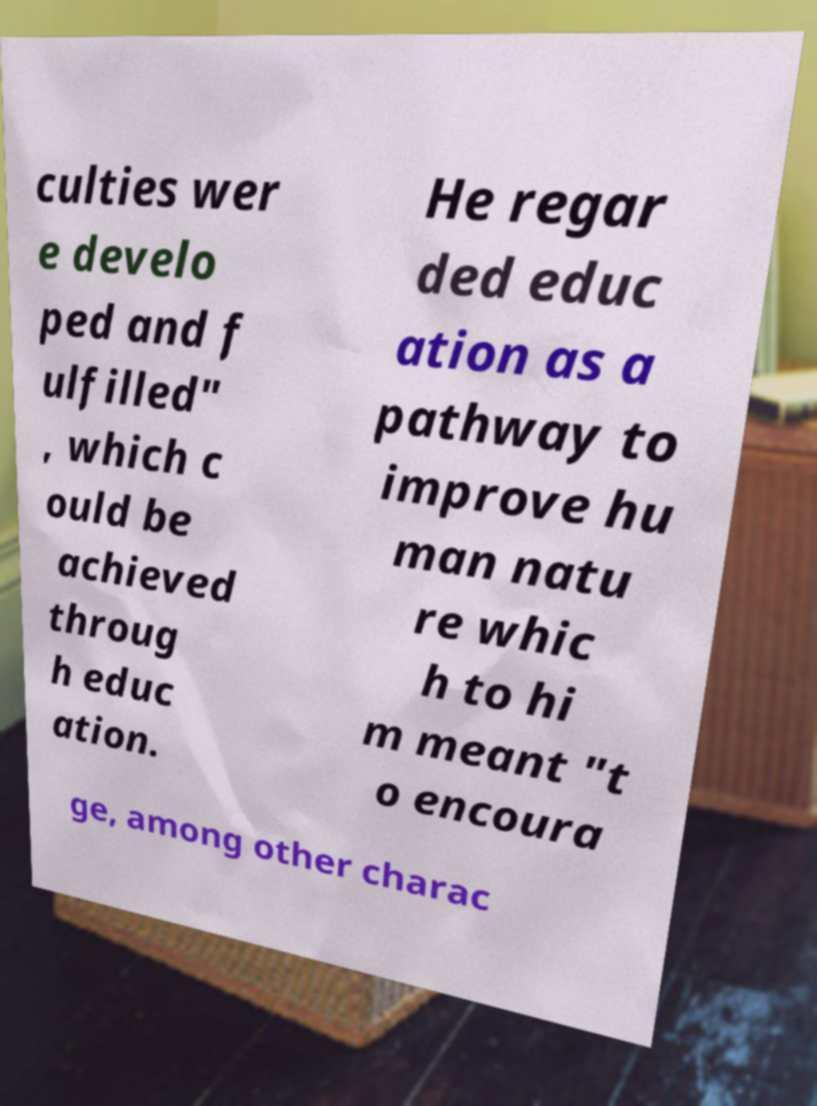What messages or text are displayed in this image? I need them in a readable, typed format. culties wer e develo ped and f ulfilled" , which c ould be achieved throug h educ ation. He regar ded educ ation as a pathway to improve hu man natu re whic h to hi m meant "t o encoura ge, among other charac 